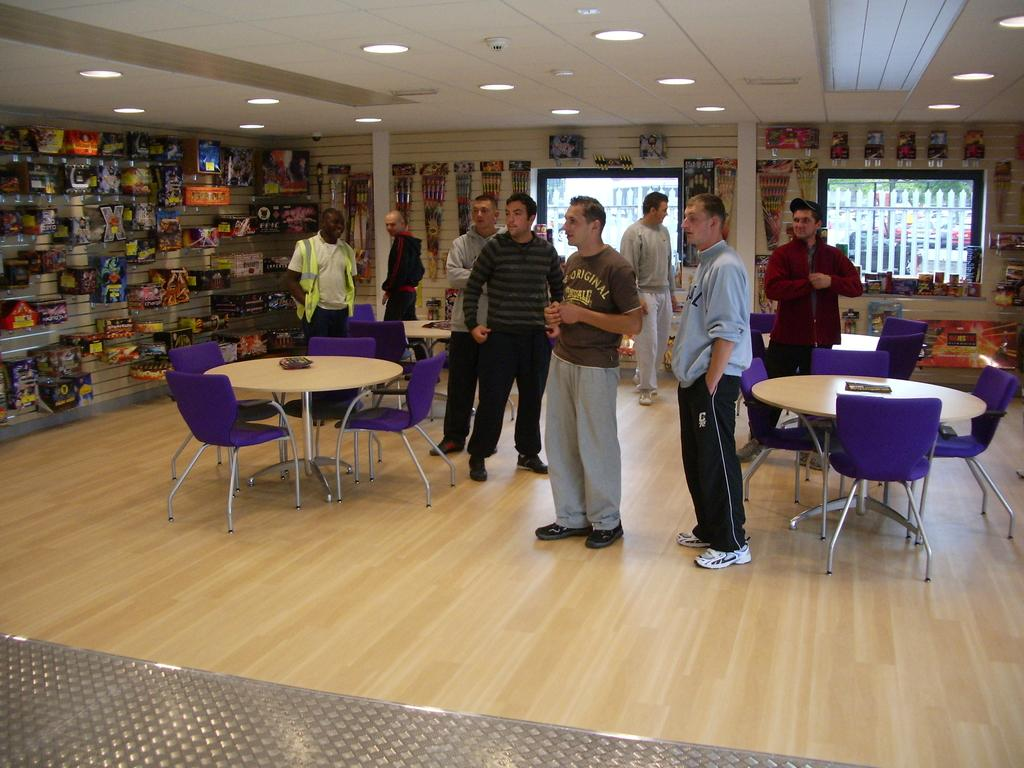What is happening in the image? There are persons standing in the image. What type of furniture is present in the image? There are tables and chairs in the image. What can be seen in the background of the image? There is a wall, a window, and objects in the background of the image. What is the source of illumination in the image? There are lights visible in the image. From what perspective was the image taken? The image is taken from a floor level. Can you see any ants crawling on the persons in the image? There are no ants visible in the image. How many seats are available for the persons to sit on in the image? The term "seat" is not mentioned in the facts, but there are chairs present in the image. 